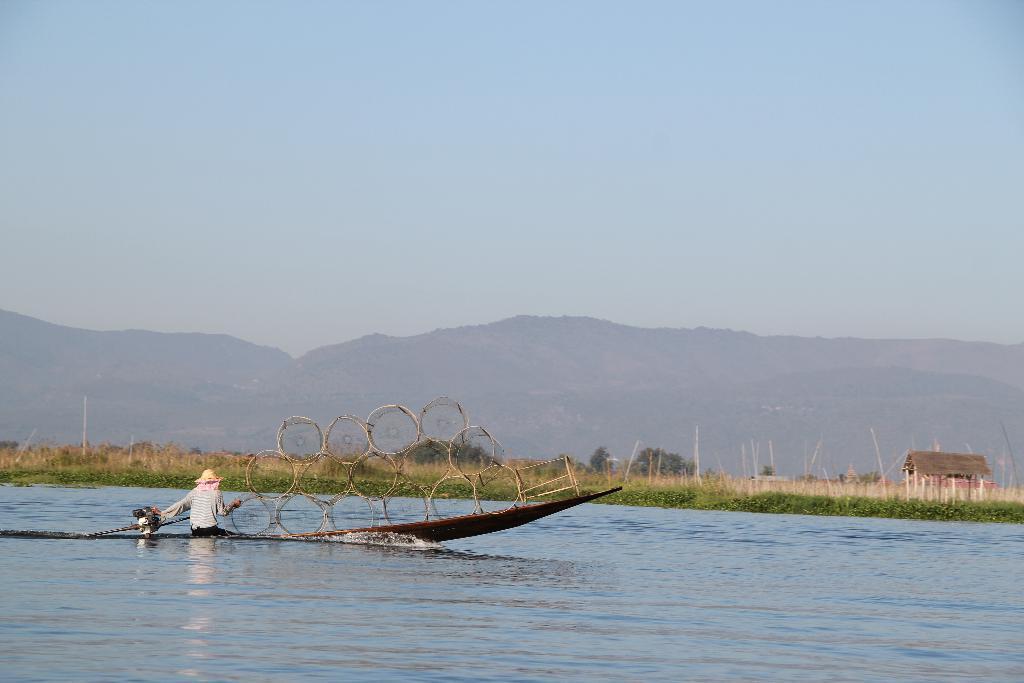Can you describe this image briefly? This is a person sitting on the boat. I can see few objects, which are kept on the boat. This looks like a lake with the water flowing. These are the trees and the grass. This looks like a small house. In the background, I can see the mountains. 